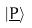Convert formula to latex. <formula><loc_0><loc_0><loc_500><loc_500>| \underline { P } \rangle</formula> 